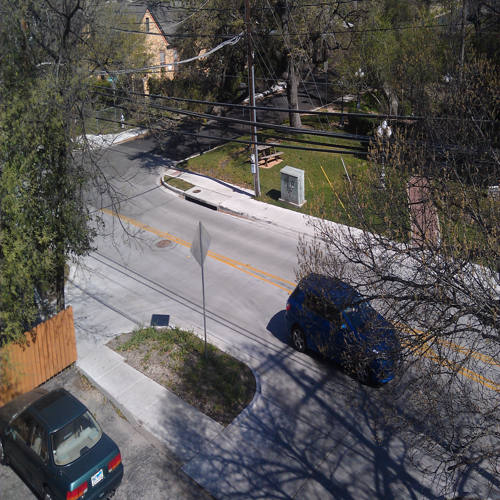Can the details and textures of the subject be recognized and distinguished?
A. No
B. Yes
C. Depends
Answer with the option's letter from the given choices directly.
 B. 